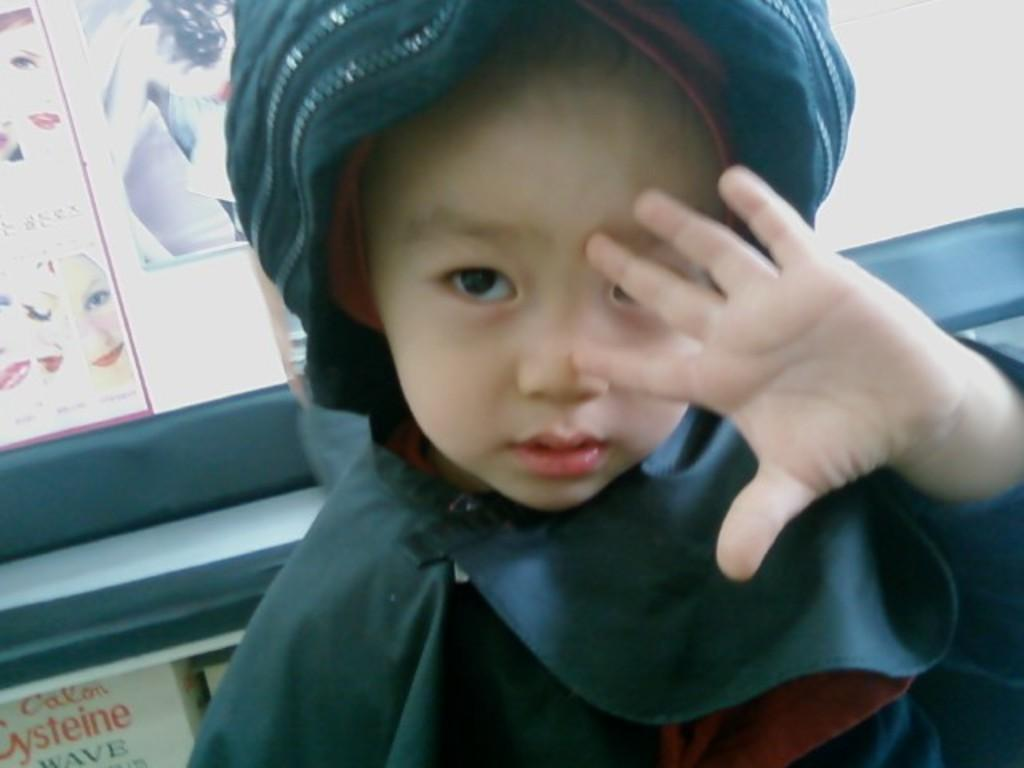What is the main subject of the image? There is a kid in the image. What can be seen in the background of the image? There is a wall in the background of the image. What is on the wall in the image? There are posters on the wall. Can you describe the content of the posters? The posters contain text and images. What type of vest can be seen on the wren in the image? There is no wren or vest present in the image. 